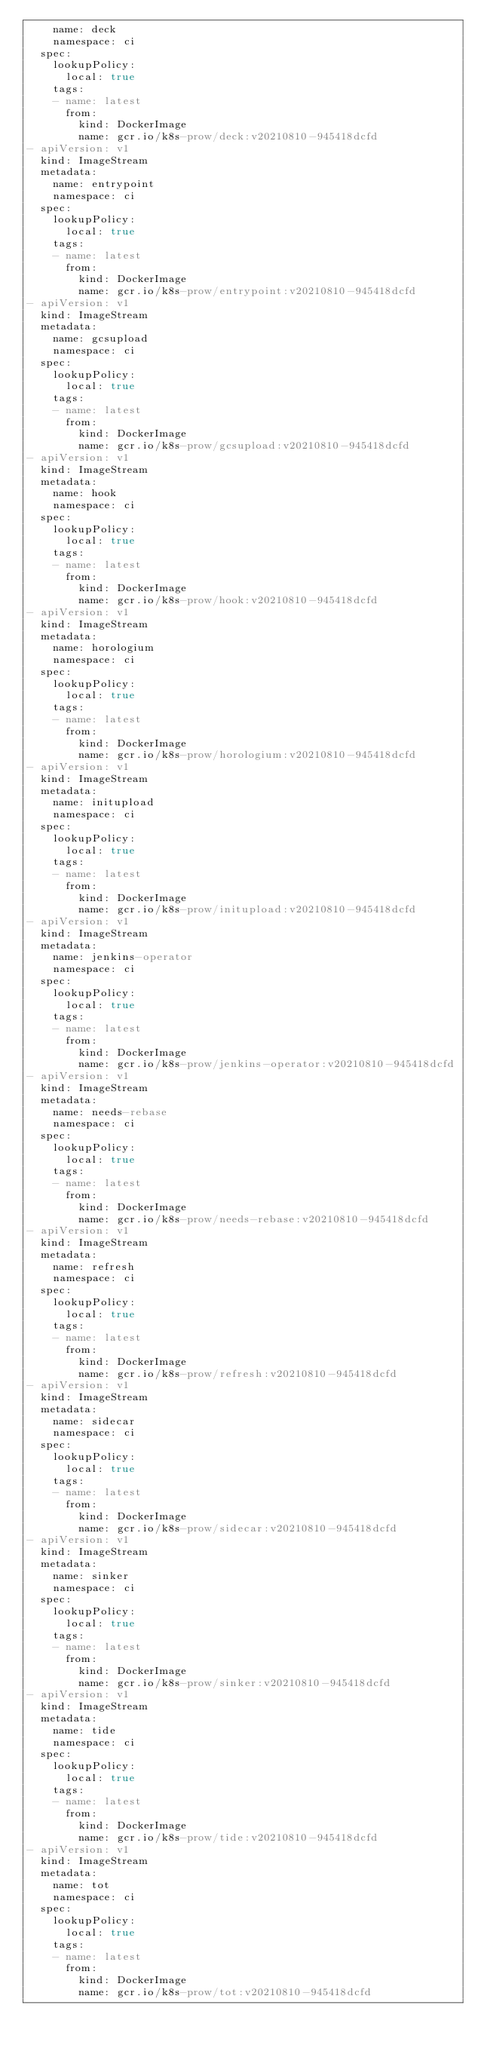Convert code to text. <code><loc_0><loc_0><loc_500><loc_500><_YAML_>    name: deck
    namespace: ci
  spec:
    lookupPolicy:
      local: true
    tags:
    - name: latest
      from:
        kind: DockerImage
        name: gcr.io/k8s-prow/deck:v20210810-945418dcfd
- apiVersion: v1
  kind: ImageStream
  metadata:
    name: entrypoint
    namespace: ci
  spec:
    lookupPolicy:
      local: true
    tags:
    - name: latest
      from:
        kind: DockerImage
        name: gcr.io/k8s-prow/entrypoint:v20210810-945418dcfd
- apiVersion: v1
  kind: ImageStream
  metadata:
    name: gcsupload
    namespace: ci
  spec:
    lookupPolicy:
      local: true
    tags:
    - name: latest
      from:
        kind: DockerImage
        name: gcr.io/k8s-prow/gcsupload:v20210810-945418dcfd
- apiVersion: v1
  kind: ImageStream
  metadata:
    name: hook
    namespace: ci
  spec:
    lookupPolicy:
      local: true
    tags:
    - name: latest
      from:
        kind: DockerImage
        name: gcr.io/k8s-prow/hook:v20210810-945418dcfd
- apiVersion: v1
  kind: ImageStream
  metadata:
    name: horologium
    namespace: ci
  spec:
    lookupPolicy:
      local: true
    tags:
    - name: latest
      from:
        kind: DockerImage
        name: gcr.io/k8s-prow/horologium:v20210810-945418dcfd
- apiVersion: v1
  kind: ImageStream
  metadata:
    name: initupload
    namespace: ci
  spec:
    lookupPolicy:
      local: true
    tags:
    - name: latest
      from:
        kind: DockerImage
        name: gcr.io/k8s-prow/initupload:v20210810-945418dcfd
- apiVersion: v1
  kind: ImageStream
  metadata:
    name: jenkins-operator
    namespace: ci
  spec:
    lookupPolicy:
      local: true
    tags:
    - name: latest
      from:
        kind: DockerImage
        name: gcr.io/k8s-prow/jenkins-operator:v20210810-945418dcfd
- apiVersion: v1
  kind: ImageStream
  metadata:
    name: needs-rebase
    namespace: ci
  spec:
    lookupPolicy:
      local: true
    tags:
    - name: latest
      from:
        kind: DockerImage
        name: gcr.io/k8s-prow/needs-rebase:v20210810-945418dcfd
- apiVersion: v1
  kind: ImageStream
  metadata:
    name: refresh
    namespace: ci
  spec:
    lookupPolicy:
      local: true
    tags:
    - name: latest
      from:
        kind: DockerImage
        name: gcr.io/k8s-prow/refresh:v20210810-945418dcfd
- apiVersion: v1
  kind: ImageStream
  metadata:
    name: sidecar
    namespace: ci
  spec:
    lookupPolicy:
      local: true
    tags:
    - name: latest
      from:
        kind: DockerImage
        name: gcr.io/k8s-prow/sidecar:v20210810-945418dcfd
- apiVersion: v1
  kind: ImageStream
  metadata:
    name: sinker
    namespace: ci
  spec:
    lookupPolicy:
      local: true
    tags:
    - name: latest
      from:
        kind: DockerImage
        name: gcr.io/k8s-prow/sinker:v20210810-945418dcfd
- apiVersion: v1
  kind: ImageStream
  metadata:
    name: tide
    namespace: ci
  spec:
    lookupPolicy:
      local: true
    tags:
    - name: latest
      from:
        kind: DockerImage
        name: gcr.io/k8s-prow/tide:v20210810-945418dcfd
- apiVersion: v1
  kind: ImageStream
  metadata:
    name: tot
    namespace: ci
  spec:
    lookupPolicy:
      local: true
    tags:
    - name: latest
      from:
        kind: DockerImage
        name: gcr.io/k8s-prow/tot:v20210810-945418dcfd
</code> 